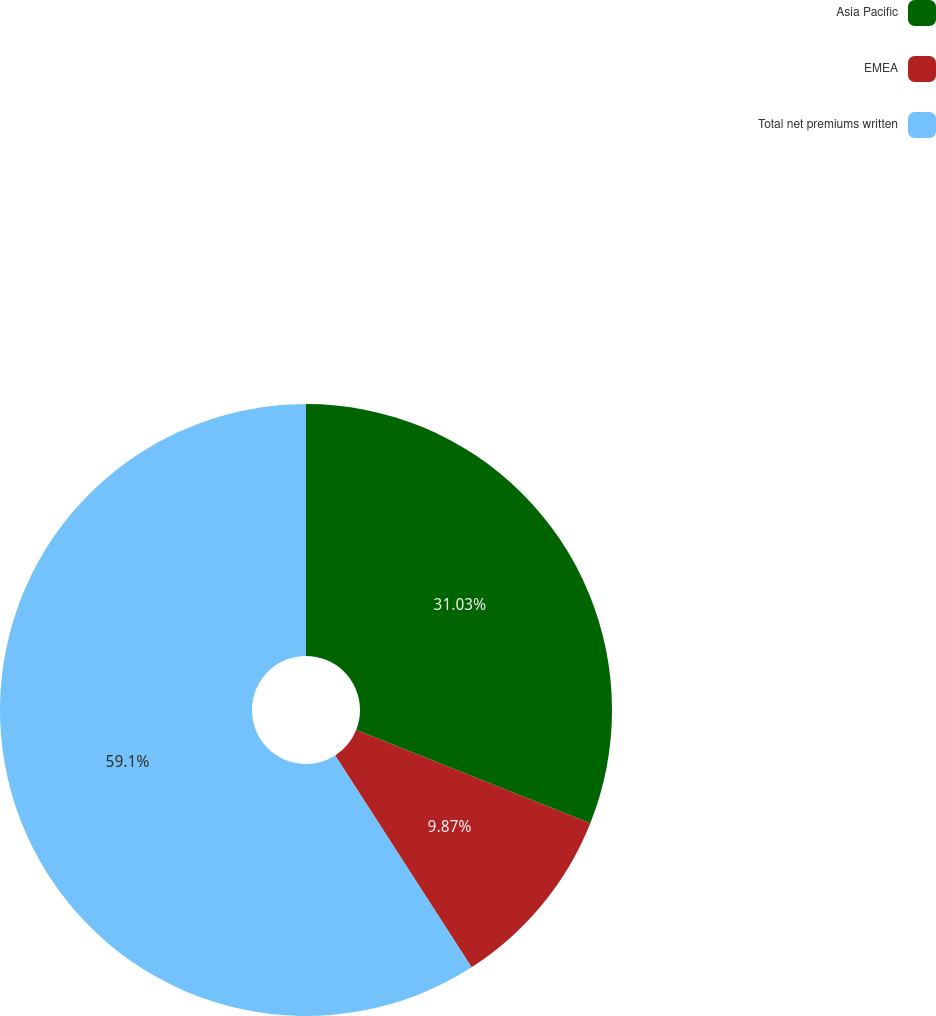Convert chart. <chart><loc_0><loc_0><loc_500><loc_500><pie_chart><fcel>Asia Pacific<fcel>EMEA<fcel>Total net premiums written<nl><fcel>31.03%<fcel>9.87%<fcel>59.1%<nl></chart> 